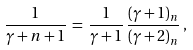Convert formula to latex. <formula><loc_0><loc_0><loc_500><loc_500>\frac { 1 } { \gamma + n + 1 } \, = \, \frac { 1 } { \gamma + 1 } \, \frac { ( \gamma + 1 ) _ { n } } { ( \gamma + 2 ) _ { n } } \, ,</formula> 